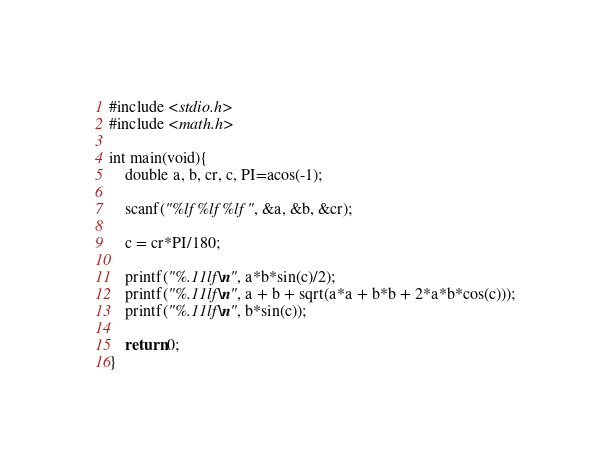<code> <loc_0><loc_0><loc_500><loc_500><_C_>#include <stdio.h>
#include <math.h>

int main(void){
    double a, b, cr, c, PI=acos(-1);
    
    scanf("%lf %lf %lf", &a, &b, &cr);

    c = cr*PI/180;
    
    printf("%.11lf\n", a*b*sin(c)/2);
    printf("%.11lf\n", a + b + sqrt(a*a + b*b + 2*a*b*cos(c)));
    printf("%.11lf\n", b*sin(c));
    
    return 0;
}

</code> 